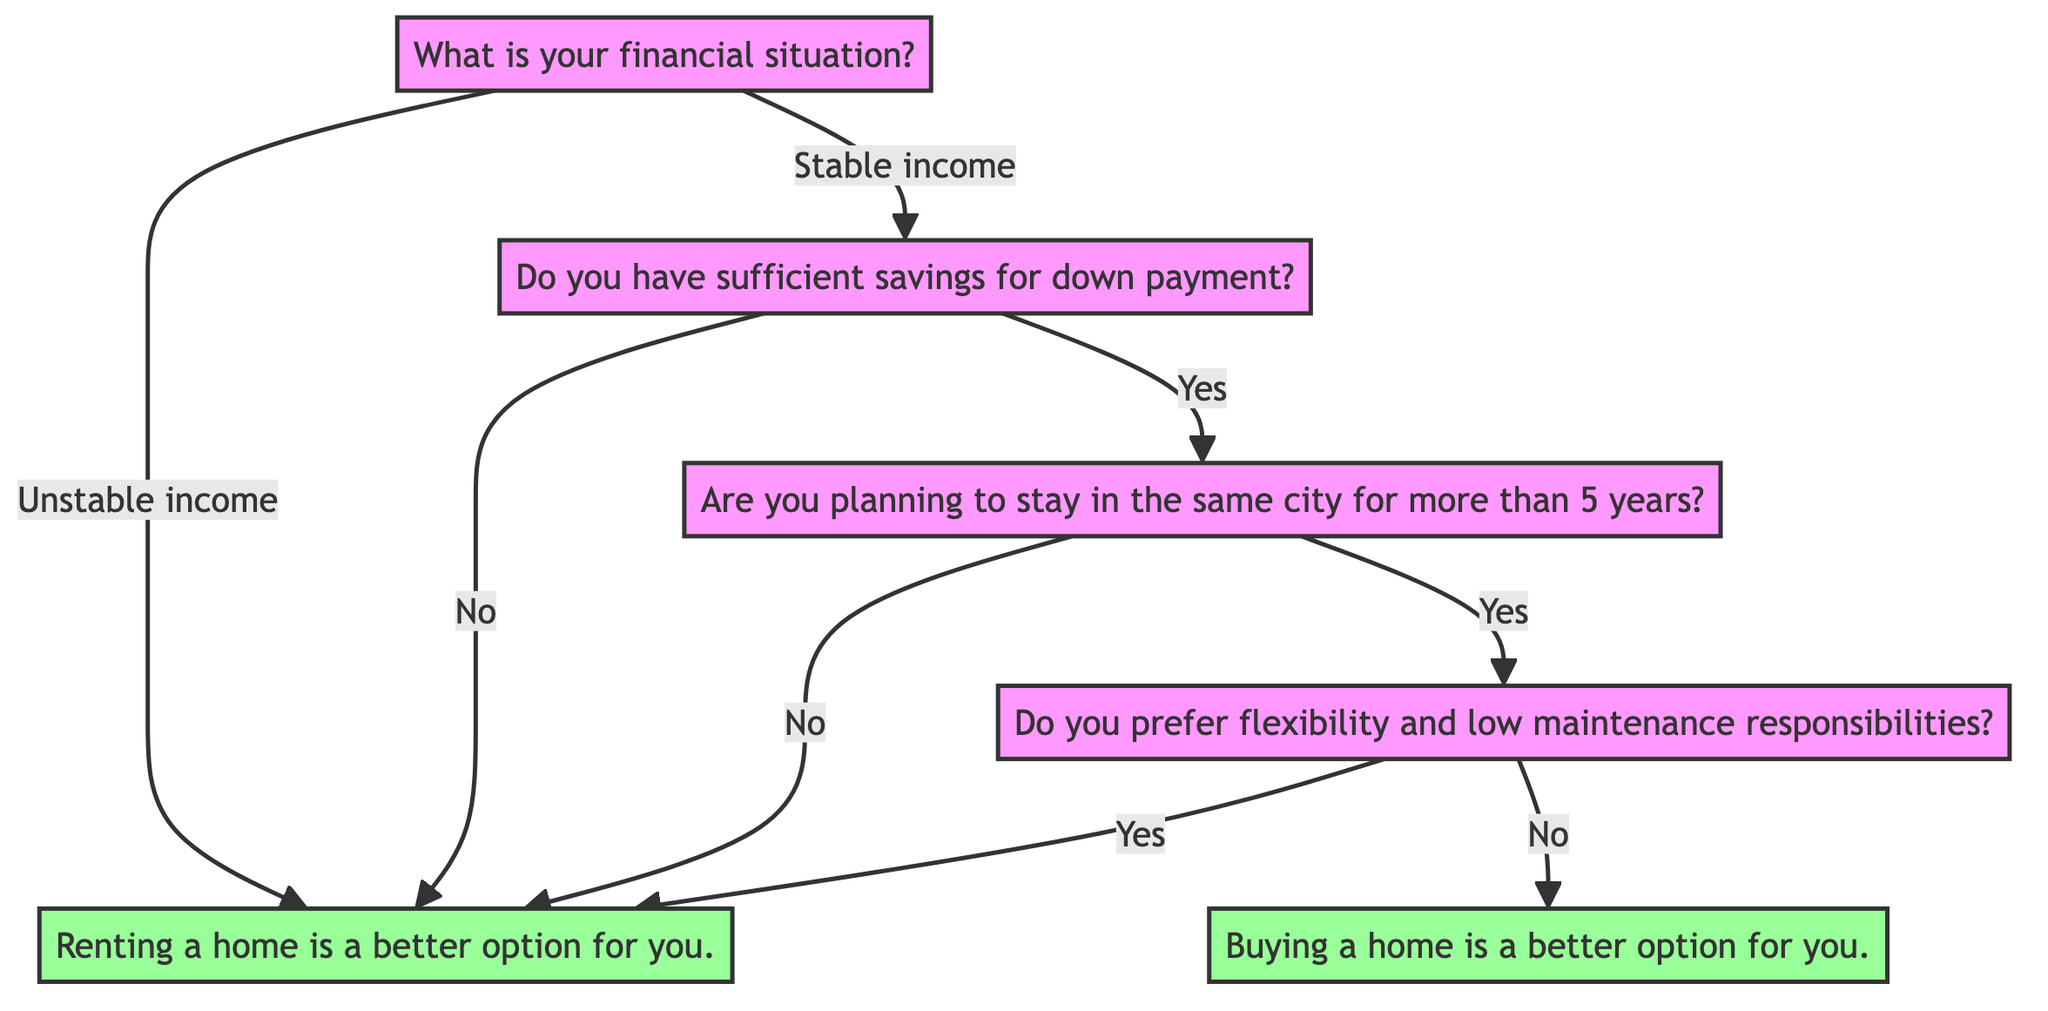What is the first question in the diagram? The first question is "What is your financial situation?" which is located at the top of the decision tree and serves as the starting point for decisions related to renting or buying a home.
Answer: What is your financial situation? How many options are there after the first question? After the first question, there are two options: "Stable income" and "Unstable income", leading to different paths in the decision tree regarding renting or buying a home.
Answer: Two options What happens if you have an unstable income? If you have an unstable income, the decision tree directs you immediately to "Rent" as the better option for housing, with no further questions being asked.
Answer: Rent What is the decision if you have stable income but no down payment? If you have a stable income but do not have sufficient savings for the down payment, the decision will lead you directly to "Rent", indicating that renting is a more suitable option for your situation.
Answer: Rent What is the next question if you have stable income and sufficient savings for a down payment? If you have stable income and sufficient savings for a down payment, the next question will be "Are you planning to stay in the same city for more than 5 years?" to further assess the suitability of buying or renting.
Answer: Are you planning to stay in the same city for more than 5 years? What decision will you reach if you are planning to stay in the same city for more than 5 years and prefer flexibility and low maintenance? If you plan to stay in the same city for more than 5 years but still prefer flexibility and low maintenance, the decision will lead you to "Rent", which suggests that renting may still be a better fit despite the long-term commitment.
Answer: Rent What are the two final housing options presented in the diagram? The two final housing options presented at the end of the decision paths are "Rent" and "Buy," each indicated as a suitable choice based on the previous answers to the questions.
Answer: Rent and Buy What should you do if you don't have sufficient savings for a down payment, even with stable income? If you don't have sufficient savings for a down payment despite having stable income, you should choose to "Rent," as indicated by the path in the diagram when this situation arises.
Answer: Rent 